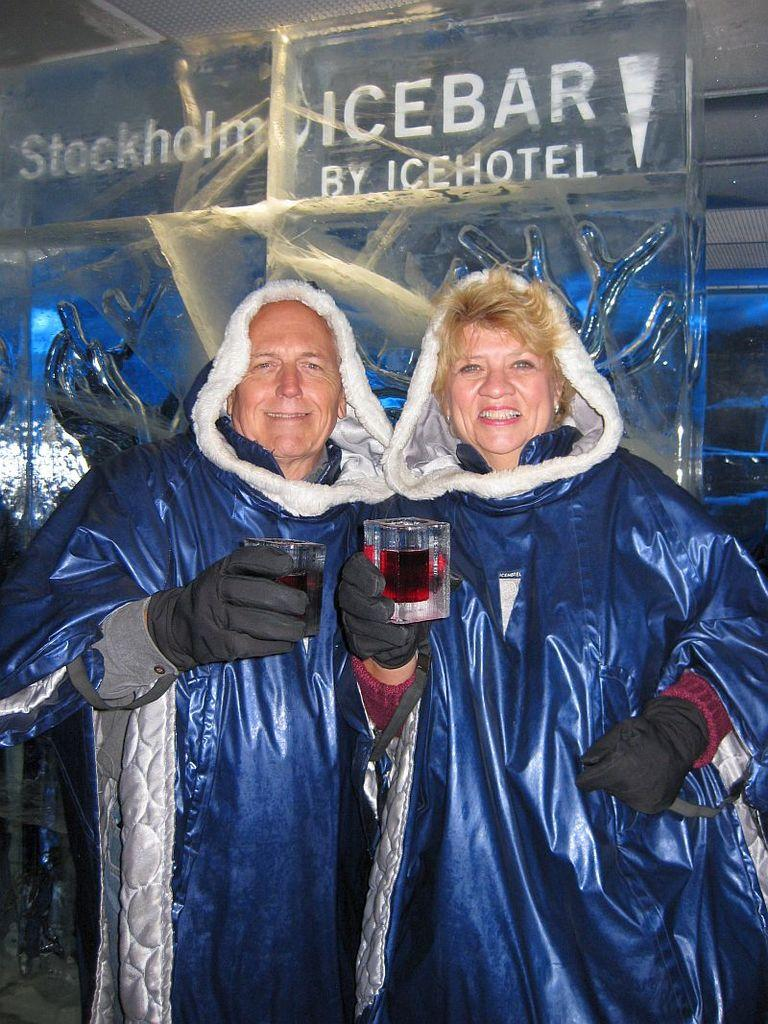Provide a one-sentence caption for the provided image. A man and a woman at an icebar hotel wearing heavy clothing while holding up glasses. 